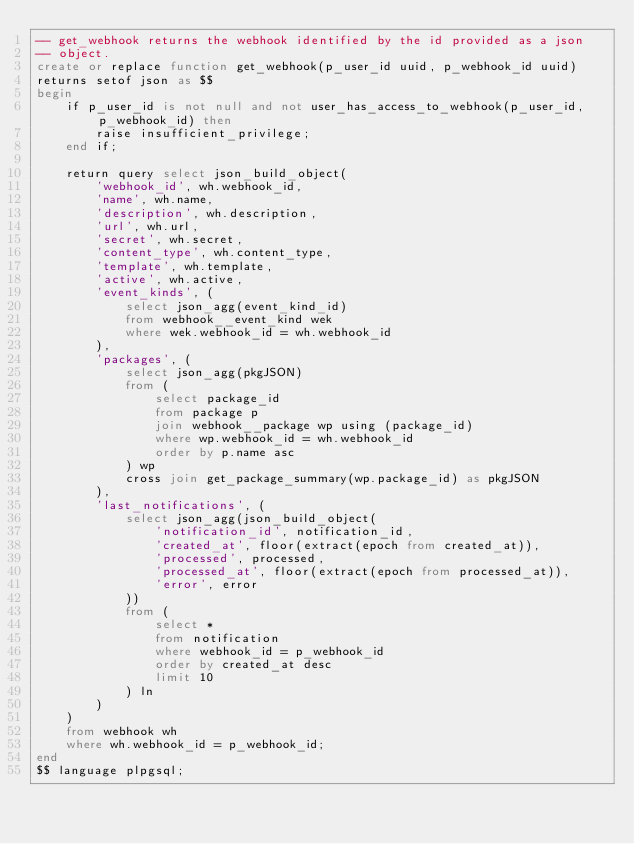<code> <loc_0><loc_0><loc_500><loc_500><_SQL_>-- get_webhook returns the webhook identified by the id provided as a json
-- object.
create or replace function get_webhook(p_user_id uuid, p_webhook_id uuid)
returns setof json as $$
begin
    if p_user_id is not null and not user_has_access_to_webhook(p_user_id, p_webhook_id) then
        raise insufficient_privilege;
    end if;

    return query select json_build_object(
        'webhook_id', wh.webhook_id,
        'name', wh.name,
        'description', wh.description,
        'url', wh.url,
        'secret', wh.secret,
        'content_type', wh.content_type,
        'template', wh.template,
        'active', wh.active,
        'event_kinds', (
            select json_agg(event_kind_id)
            from webhook__event_kind wek
            where wek.webhook_id = wh.webhook_id
        ),
        'packages', (
            select json_agg(pkgJSON)
            from (
                select package_id
                from package p
                join webhook__package wp using (package_id)
                where wp.webhook_id = wh.webhook_id
                order by p.name asc
            ) wp
            cross join get_package_summary(wp.package_id) as pkgJSON
        ),
        'last_notifications', (
            select json_agg(json_build_object(
                'notification_id', notification_id,
                'created_at', floor(extract(epoch from created_at)),
                'processed', processed,
                'processed_at', floor(extract(epoch from processed_at)),
                'error', error
            ))
            from (
                select *
                from notification
                where webhook_id = p_webhook_id
                order by created_at desc
                limit 10
            ) ln
        )
    )
    from webhook wh
    where wh.webhook_id = p_webhook_id;
end
$$ language plpgsql;
</code> 